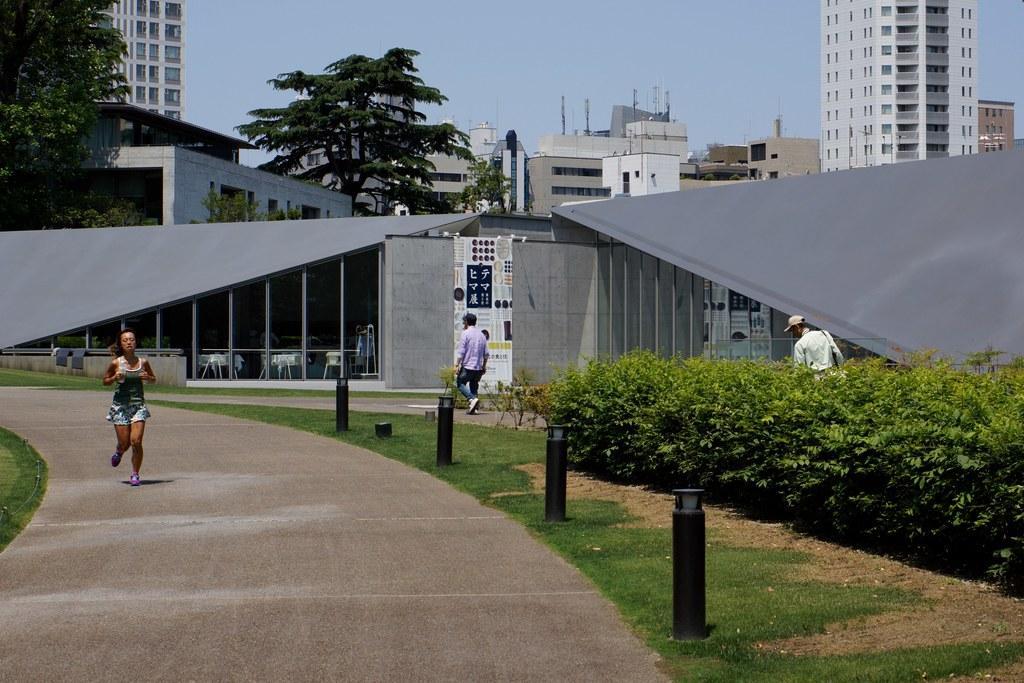Describe this image in one or two sentences. In this image I can see trees, plants and people among this woman is running on the road. I can also see poles, the grass, chairs and other objects on the ground. In the background I can see trees and the sky. 